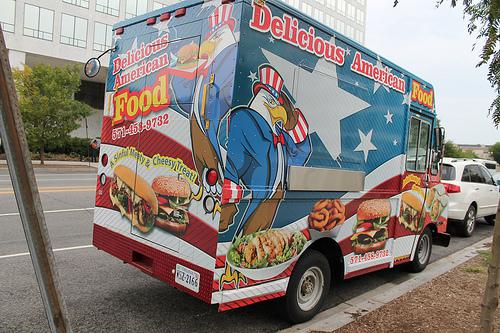Question: what is the name of the trucks in focus?
Choices:
A. Big Boy.
B. Delicious American Food.
C. American Feast.
D. Delectable Eats.
Answer with the letter. Answer: B Question: what is Delicious American Food's number?
Choices:
A. (671)-458-9732.
B. (671)-459-9732.
C. (671)-495-9732.
D. (671)-467-9732.
Answer with the letter. Answer: A Question: what endangered animal is featured on the truck?
Choices:
A. A sparrow.
B. A bald eagle.
C. A humming bird.
D. A raven.
Answer with the letter. Answer: B Question: how many vehicles are visible?
Choices:
A. Three.
B. Two.
C. One.
D. Eight.
Answer with the letter. Answer: B Question: what material is the post that holds up the sign behind the truck?
Choices:
A. Metal.
B. Wood.
C. Plastic.
D. Chains.
Answer with the letter. Answer: A 